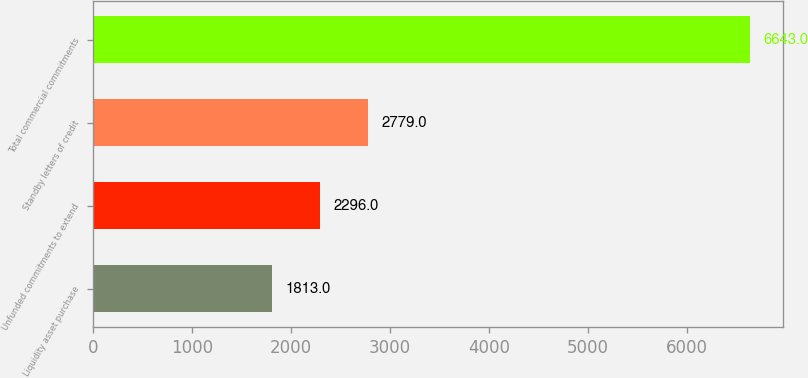<chart> <loc_0><loc_0><loc_500><loc_500><bar_chart><fcel>Liquidity asset purchase<fcel>Unfunded commitments to extend<fcel>Standby letters of credit<fcel>Total commercial commitments<nl><fcel>1813<fcel>2296<fcel>2779<fcel>6643<nl></chart> 